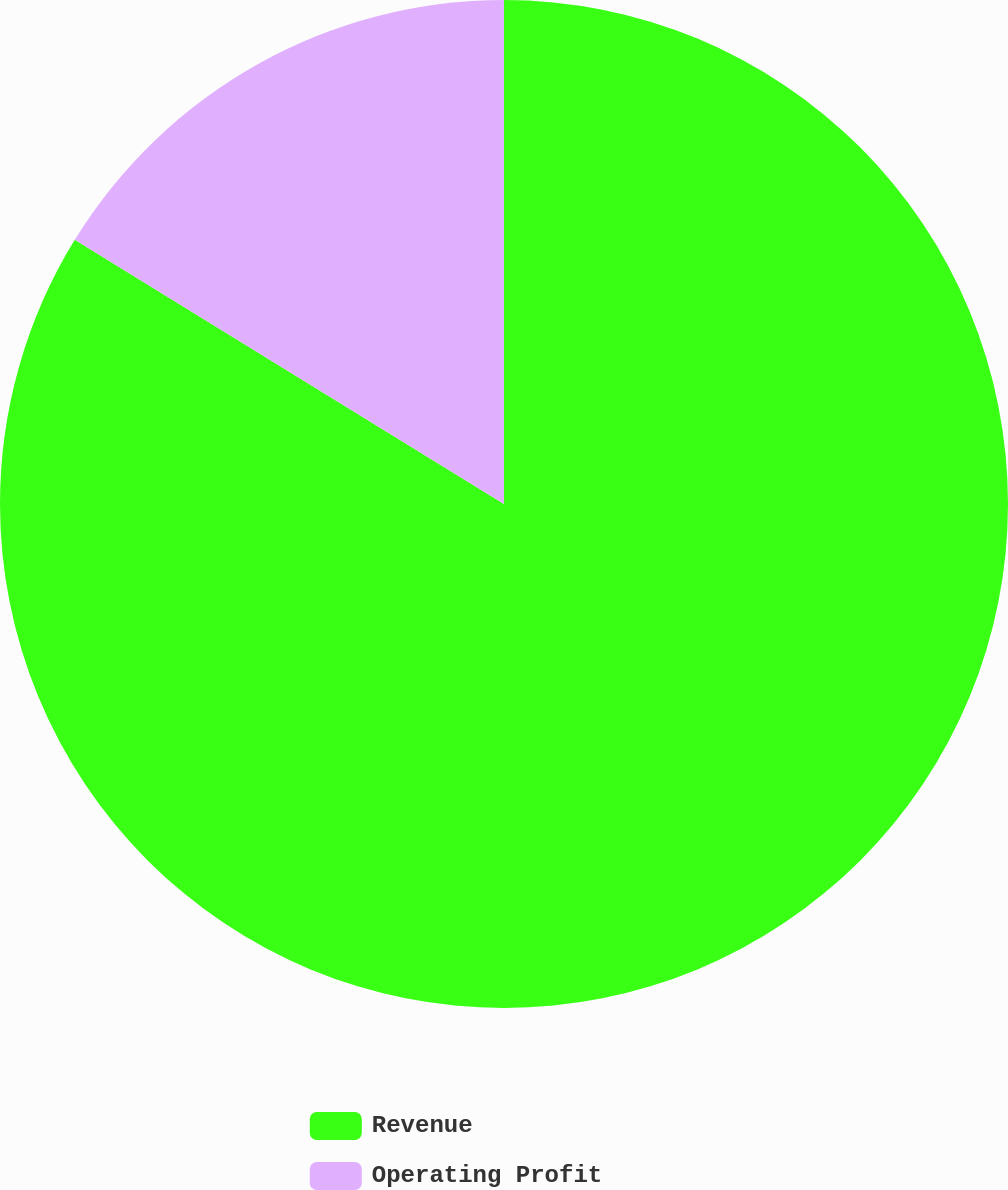Convert chart. <chart><loc_0><loc_0><loc_500><loc_500><pie_chart><fcel>Revenue<fcel>Operating Profit<nl><fcel>83.78%<fcel>16.22%<nl></chart> 